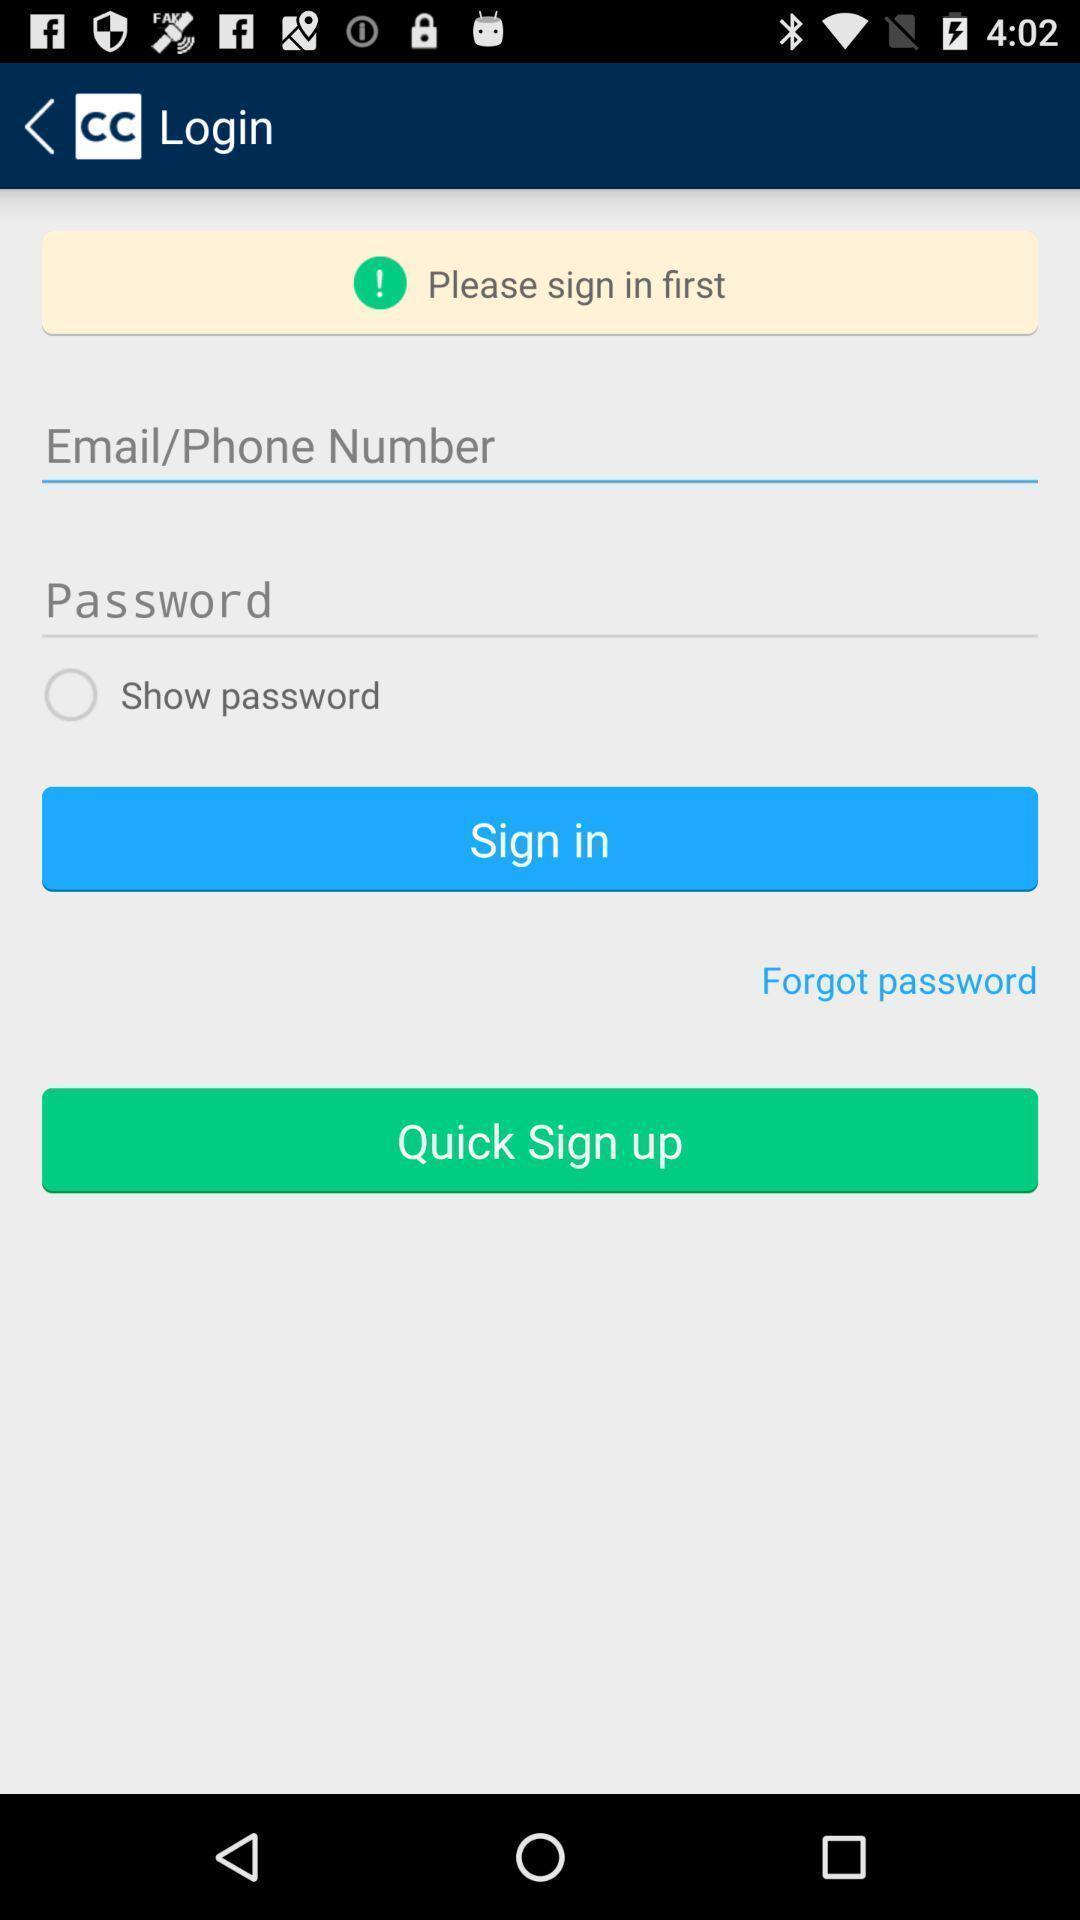Summarize the main components in this picture. Sign in page. 